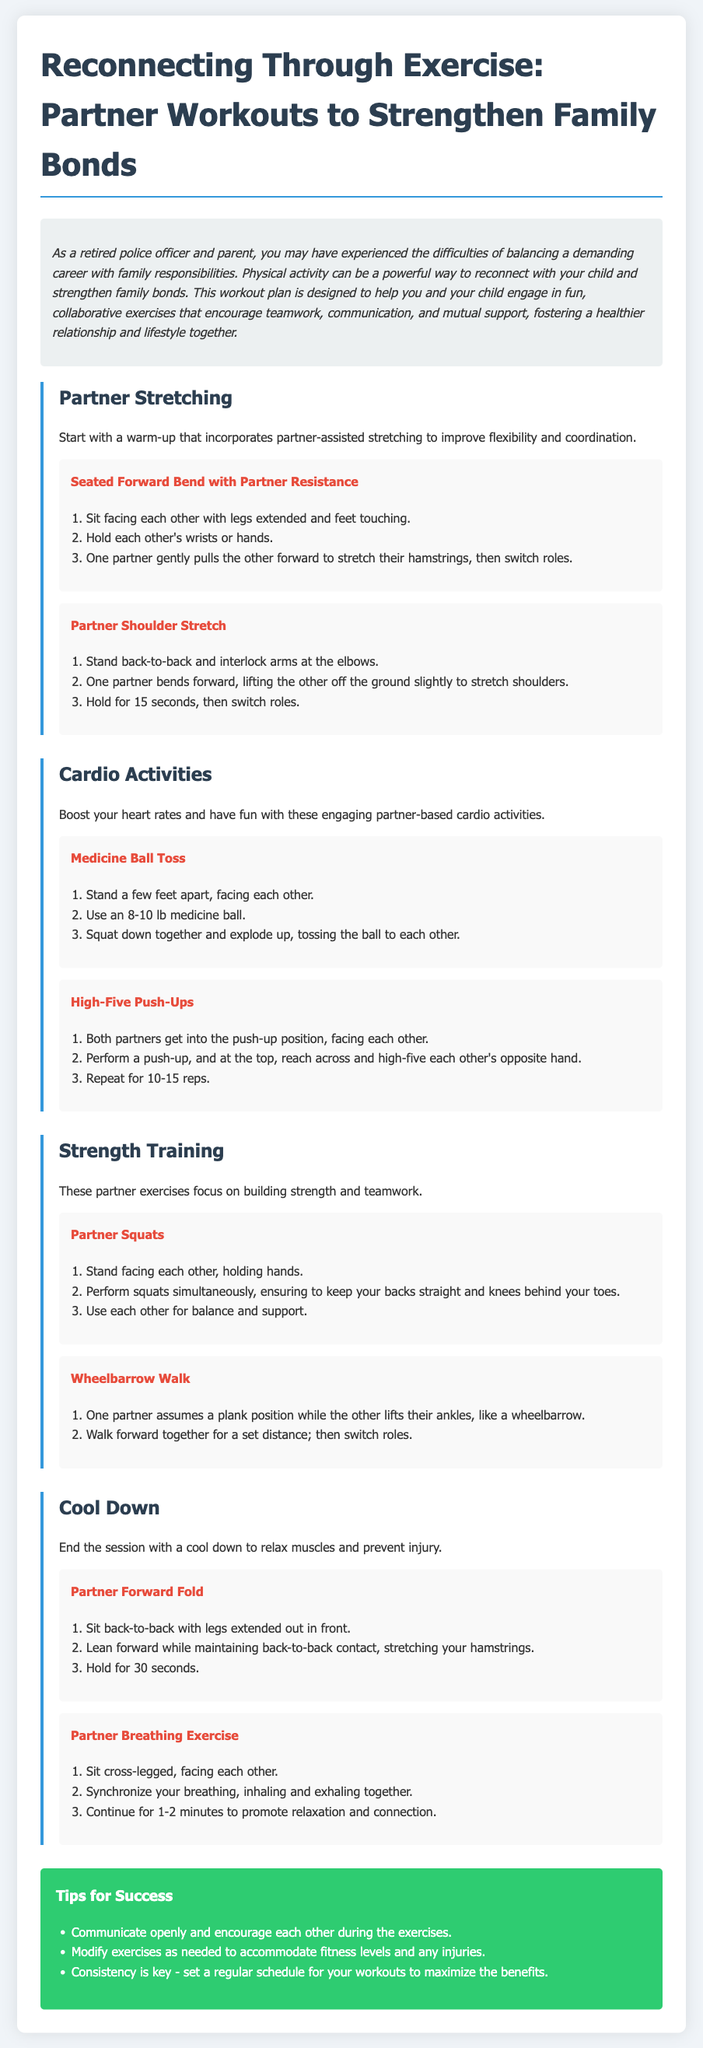what is the title of the document? The title of the document is clearly stated at the top of the rendered content.
Answer: Reconnecting Through Exercise: Partner Workouts to Strengthen Family Bonds how many unique workout sections are there? The document lists different workout sections, counting them gives the total number of sections present.
Answer: 4 what is one exercise in the Partner Stretching section? By reviewing the Partner Stretching section, we can identify specific exercises listed there.
Answer: Seated Forward Bend with Partner Resistance how long should the Partner Breathing Exercise be continued? The document specifies the duration for this exercise in the instructions provided.
Answer: 1-2 minutes what is a suggested tip for success in partner workouts? The document provides various tips, any of which can serve as an answer.
Answer: Communicate openly and encourage each other during the exercises which equipment is recommended for the Medicine Ball Toss? The document specifies the equipment required for the Medicine Ball Toss exercise.
Answer: 8-10 lb medicine ball 